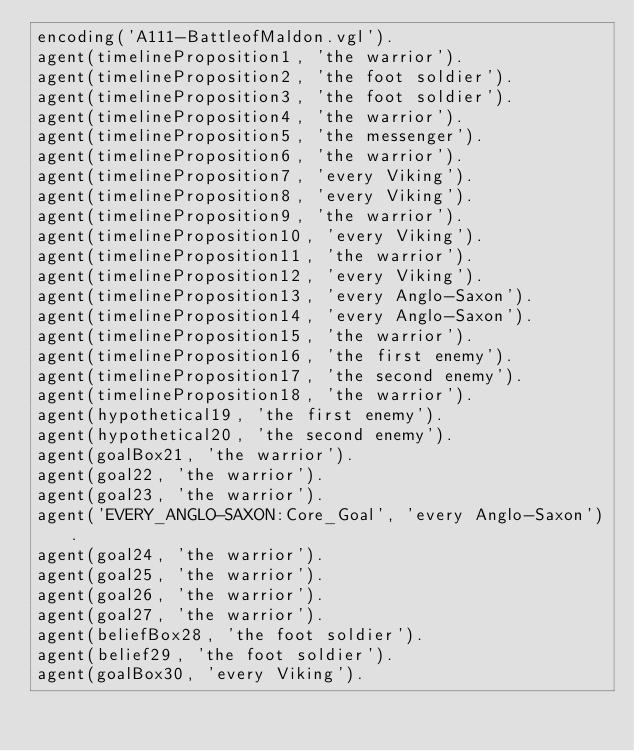<code> <loc_0><loc_0><loc_500><loc_500><_Prolog_>encoding('A111-BattleofMaldon.vgl').
agent(timelineProposition1, 'the warrior').
agent(timelineProposition2, 'the foot soldier').
agent(timelineProposition3, 'the foot soldier').
agent(timelineProposition4, 'the warrior').
agent(timelineProposition5, 'the messenger').
agent(timelineProposition6, 'the warrior').
agent(timelineProposition7, 'every Viking').
agent(timelineProposition8, 'every Viking').
agent(timelineProposition9, 'the warrior').
agent(timelineProposition10, 'every Viking').
agent(timelineProposition11, 'the warrior').
agent(timelineProposition12, 'every Viking').
agent(timelineProposition13, 'every Anglo-Saxon').
agent(timelineProposition14, 'every Anglo-Saxon').
agent(timelineProposition15, 'the warrior').
agent(timelineProposition16, 'the first enemy').
agent(timelineProposition17, 'the second enemy').
agent(timelineProposition18, 'the warrior').
agent(hypothetical19, 'the first enemy').
agent(hypothetical20, 'the second enemy').
agent(goalBox21, 'the warrior').
agent(goal22, 'the warrior').
agent(goal23, 'the warrior').
agent('EVERY_ANGLO-SAXON:Core_Goal', 'every Anglo-Saxon').
agent(goal24, 'the warrior').
agent(goal25, 'the warrior').
agent(goal26, 'the warrior').
agent(goal27, 'the warrior').
agent(beliefBox28, 'the foot soldier').
agent(belief29, 'the foot soldier').
agent(goalBox30, 'every Viking').</code> 